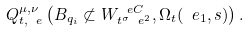<formula> <loc_0><loc_0><loc_500><loc_500>Q _ { t , \ e } ^ { \mu , \nu } \left ( B _ { q _ { i } } \not \subset W _ { t ^ { \sigma } \ e ^ { 2 } } ^ { \ e C } , \Omega _ { t } ( \ e _ { 1 } , s ) \right ) .</formula> 